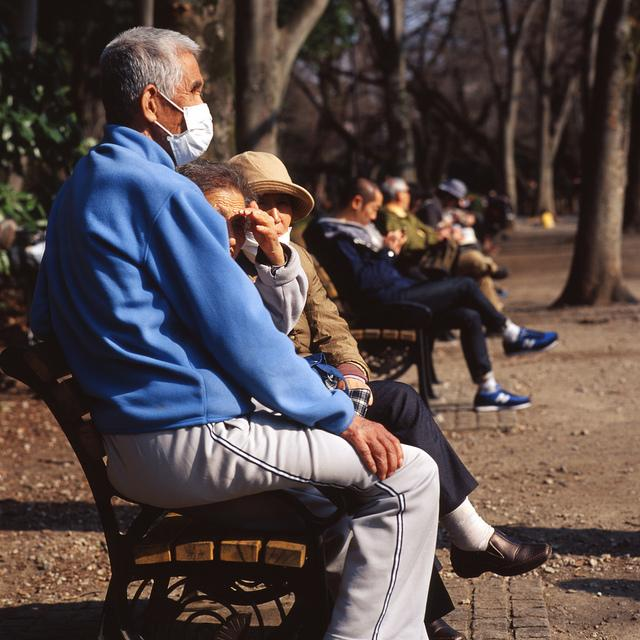What should the woman sitting in the middle wear for protection? mask 